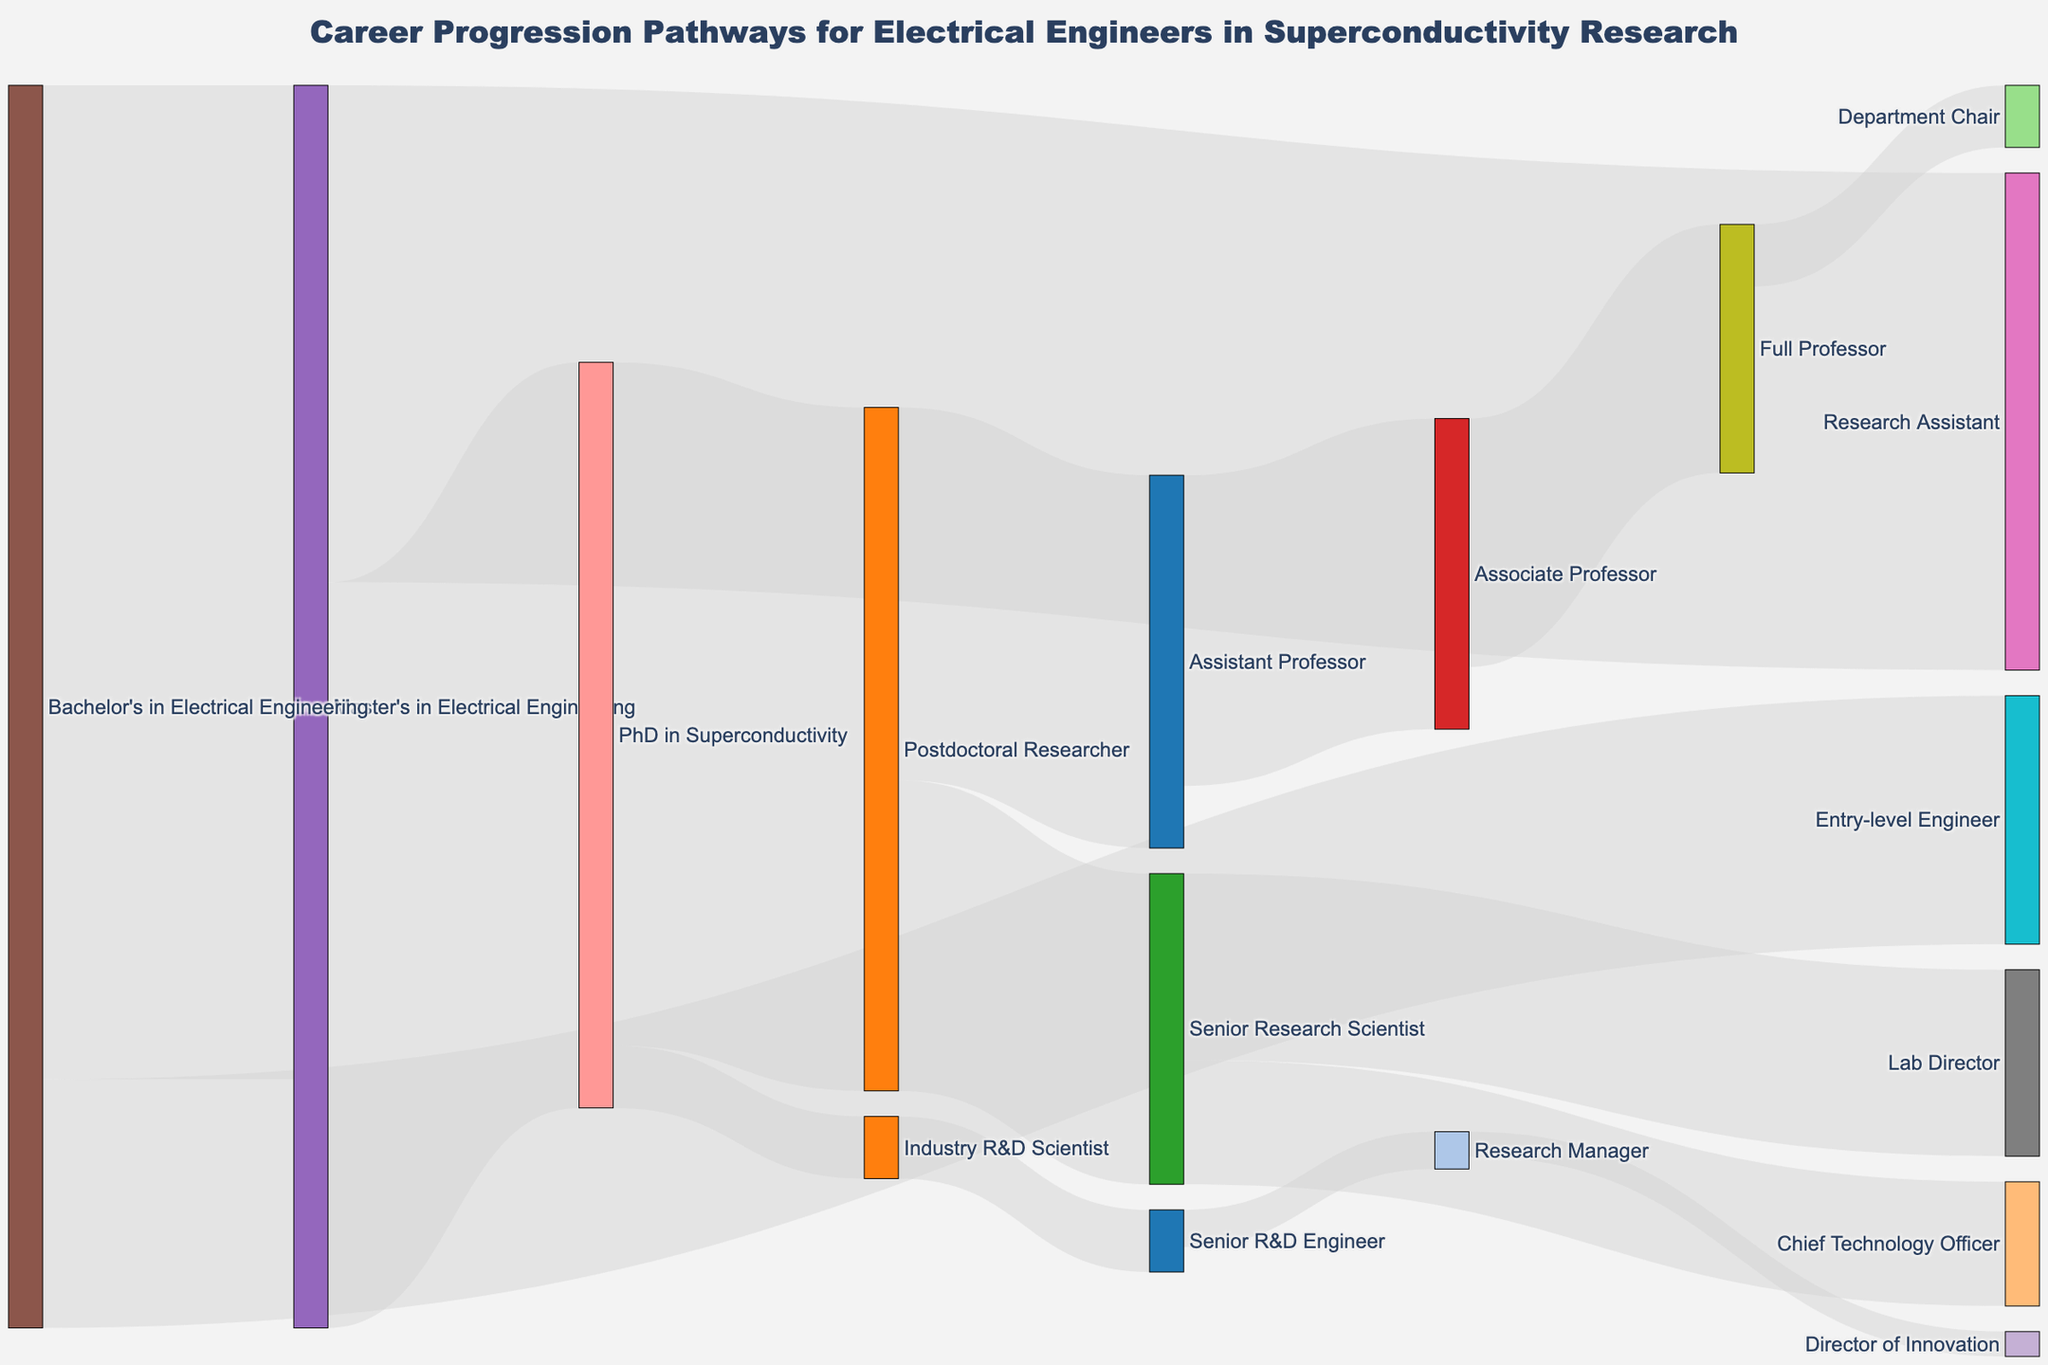What's the starting point for most career pathways on this diagram? Most pathways begin with a Bachelor's in Electrical Engineering. By observing the diagram, we can see that a significant number of links stem from this node, indicating it's a common starting point.
Answer: Bachelor's in Electrical Engineering What percentage of individuals with a Master's in Electrical Engineering move on to a PhD in Superconductivity? From the diagram, we see that 60 individuals out of a total of 120 with a Master's in Electrical Engineering move on to a PhD in Superconductivity. To find the percentage, calculate (60/100) * 100.
Answer: 60% Which pathway has the highest flow of individuals? By examining the width of the flows, we can identify that the pathway from a Bachelor's in Electrical Engineering to a Master's in Electrical Engineering has the highest value at 80.
Answer: Bachelor's to Master's in Electrical Engineering How many end up as Full Professors after starting with a Bachelor's in Electrical Engineering? To trace this pathway:
1. Begin with Bachelor's in Electrical Engineering.
2. Move to Master's (80 individuals).
3. From Master's to PhD (60).
4. PhD to Postdoctoral Researcher (55).
5. Postdoc to Assistant Professor (30).
6. Assistant to Associate Professor (25).
7. Associate to Full Professor (20).
By following this sequence, we see that 20 individuals follow this pathway.
Answer: 20 What’s the proportion of PhD graduates in Superconductivity who join the industry as opposed to academia? To find this:
1. Industry R&D Scientist: 5
2. Postdoctoral Researcher: 55
Calculate the total PhD grads: 5 + 55 = 60.
Proportion in industry: 5/60. Proportion in academia: 55/60.
Thus, comparing these values, the diagrams show a higher number in academia.
Answer: 1:11 By how many individuals do Research Assistants outnumber Entry-level Engineers from the Bachelor's degree point? From the Bachelor's node, Entry-level Engineers are 20 and those continuing to Master's are 80. From Master's, 40 become Research Assistants. So, Research Assistants = 40, Entry-level Engineers = 20. The difference is 40 - 20.
Answer: 20 What percentage of Postdoctoral Researchers advance to become Senior Research Scientists? From diagram: 25 out of 55 Postdoctoral Researchers advance to Senior Research Scientists. Calculate the percentage: (25/55) * 100.
Answer: 45.45% How many career pathways are represented in the diagram? Each unique link between nodes represents a career pathway. Counting these links in the data leads to 16 distinct pathways.
Answer: 16 Where do most Senior Research Scientists end up? From the node “Senior Research Scientist,” we see two flows: 15 move to Lab Director and 10 to Chief Technology Officer. The highest value here is Lab Director.
Answer: Lab Director 